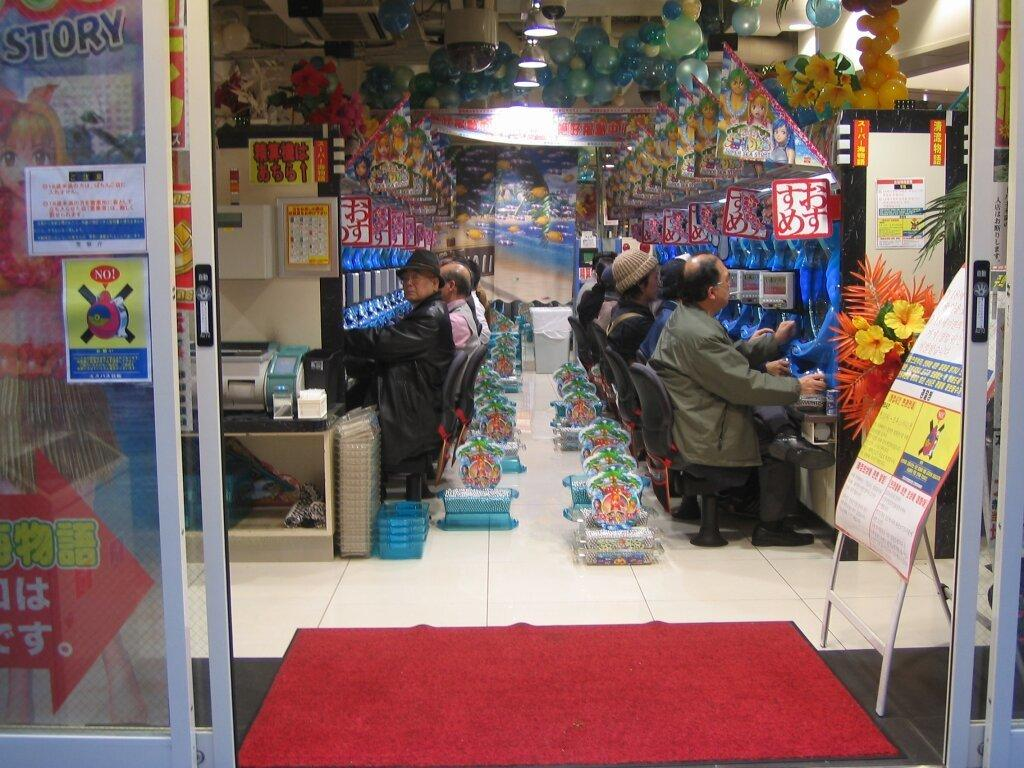<image>
Present a compact description of the photo's key features. People playing video games inside an arcade with a sign that says Story in front. 